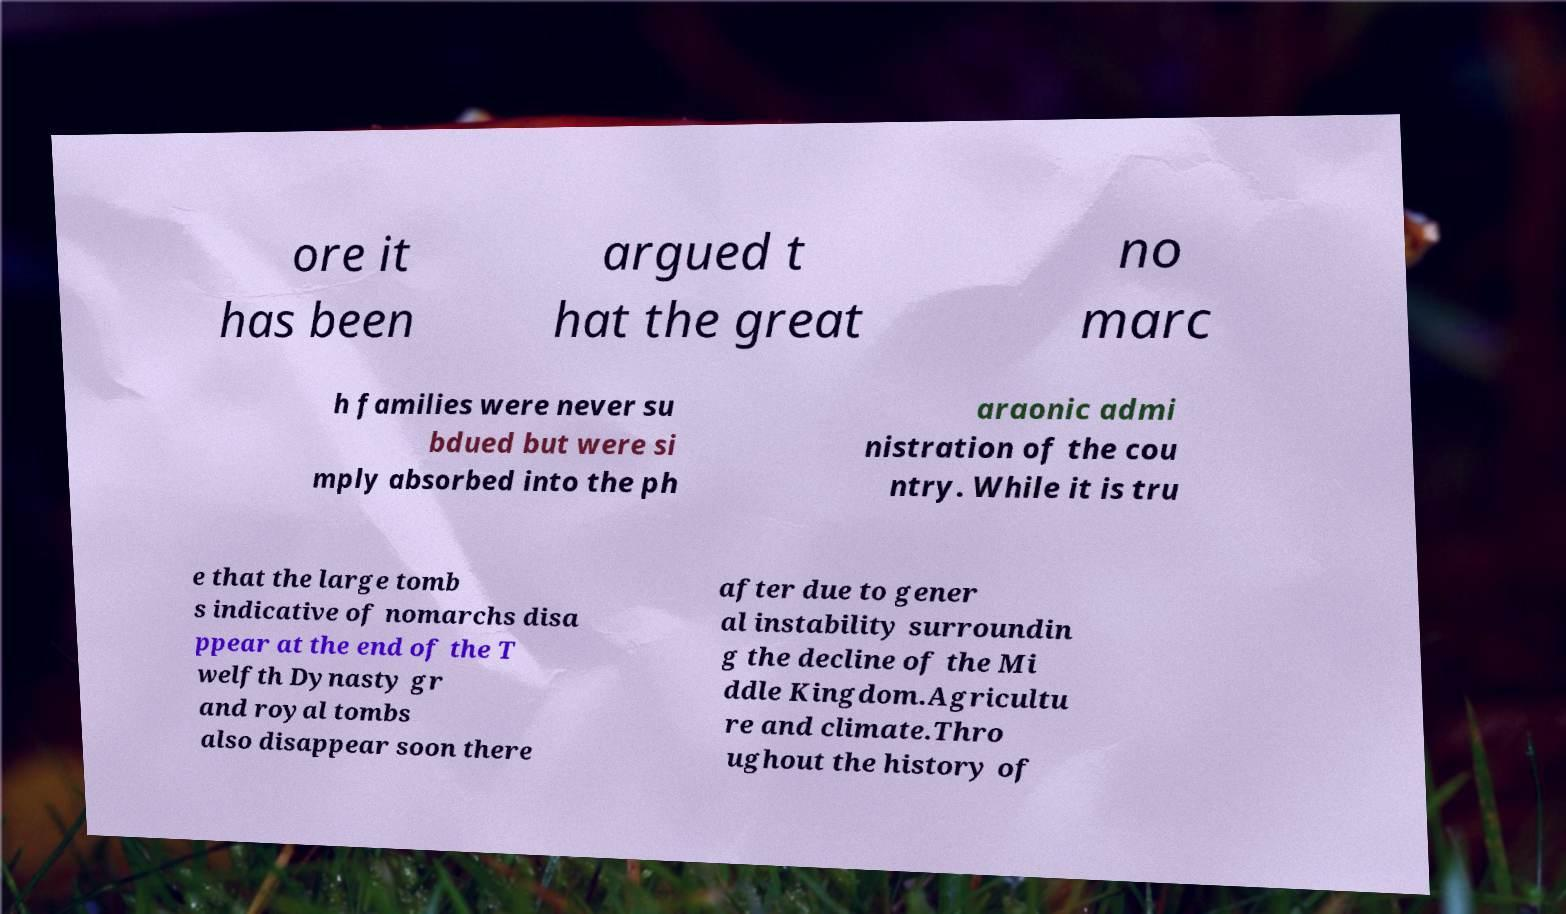For documentation purposes, I need the text within this image transcribed. Could you provide that? ore it has been argued t hat the great no marc h families were never su bdued but were si mply absorbed into the ph araonic admi nistration of the cou ntry. While it is tru e that the large tomb s indicative of nomarchs disa ppear at the end of the T welfth Dynasty gr and royal tombs also disappear soon there after due to gener al instability surroundin g the decline of the Mi ddle Kingdom.Agricultu re and climate.Thro ughout the history of 